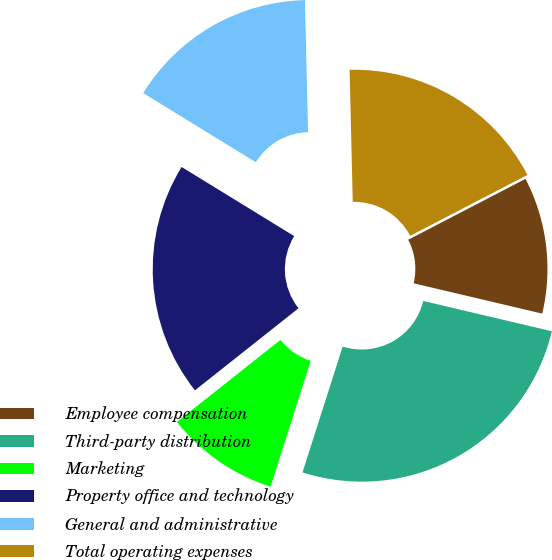Convert chart to OTSL. <chart><loc_0><loc_0><loc_500><loc_500><pie_chart><fcel>Employee compensation<fcel>Third-party distribution<fcel>Marketing<fcel>Property office and technology<fcel>General and administrative<fcel>Total operating expenses<nl><fcel>11.31%<fcel>26.23%<fcel>9.42%<fcel>19.43%<fcel>15.86%<fcel>17.75%<nl></chart> 